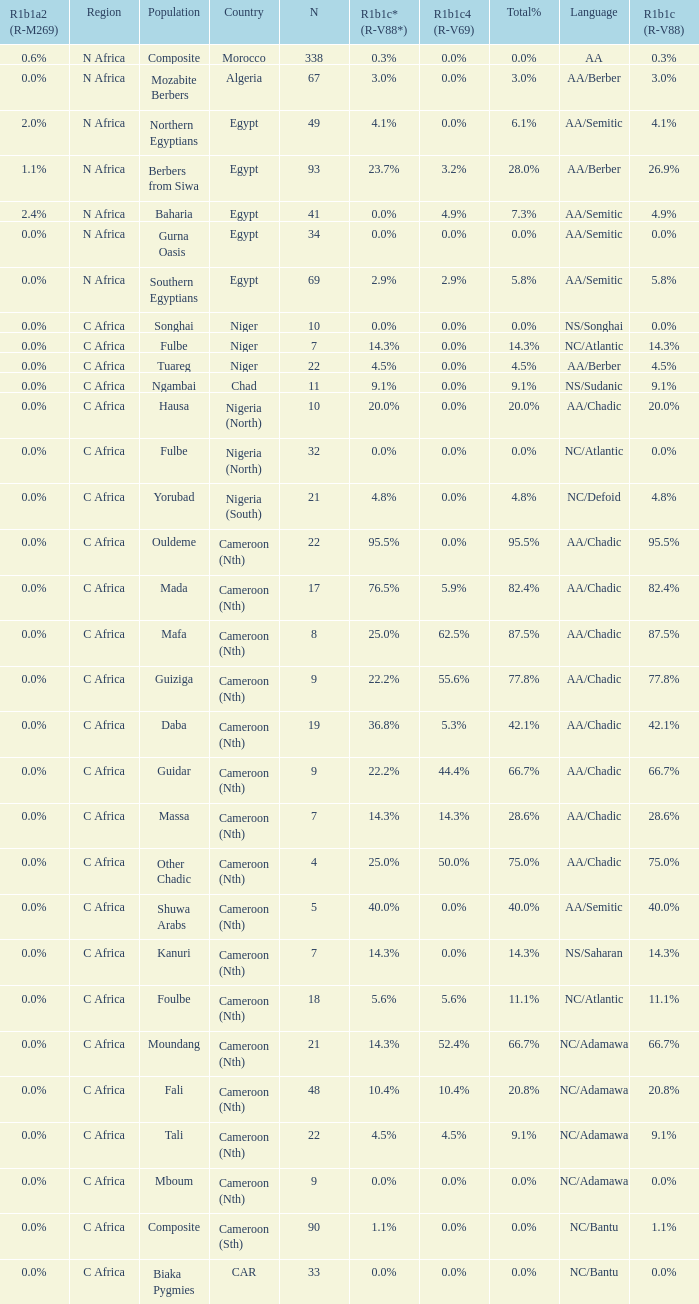6% r1b1a2 (r-m269)? 1.0. 